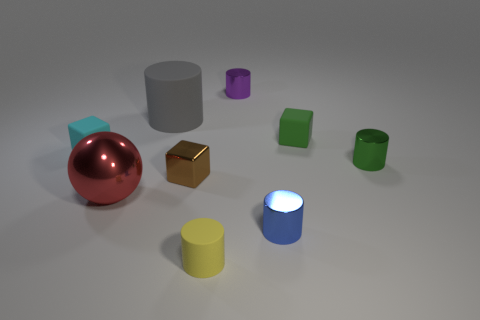What time of day does the lighting in the scene suggest? The soft shadows and neutral lighting suggest an overcast day where the sun is diffused by clouds, or an indoor setting with ambient lighting from an unseen source. 